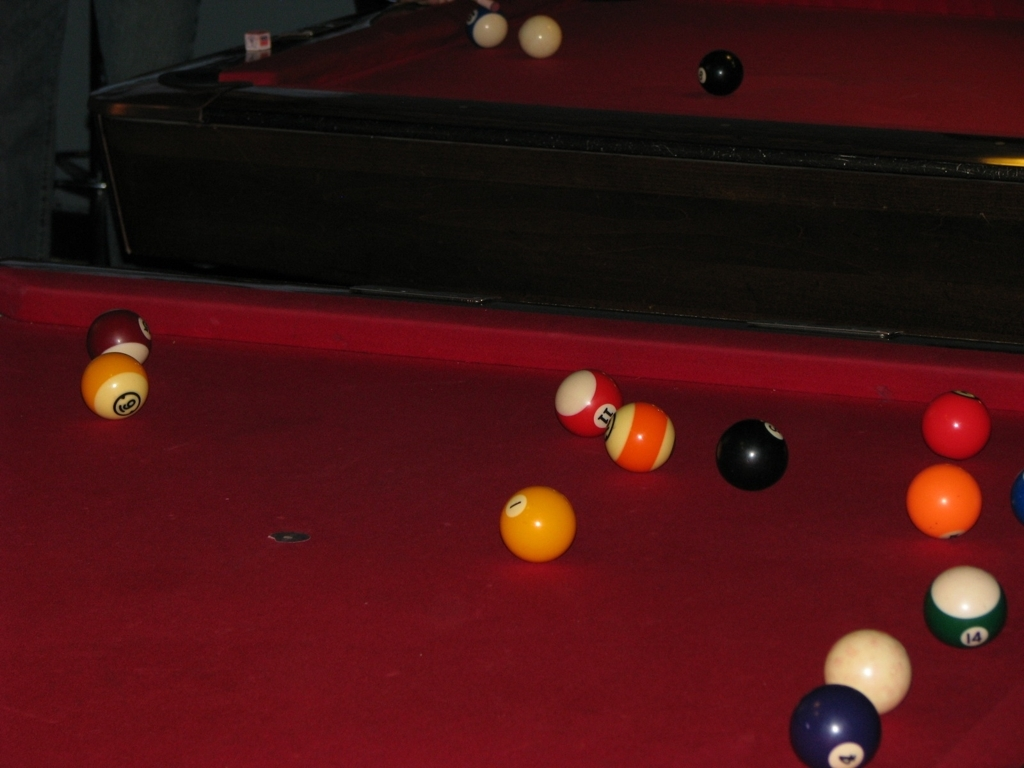How is the lighting in this image?
A. The lighting in this image is terrible, with dull colors.
B. The lighting in this image is acceptable, with vibrant colors.
C. The lighting in this image is outstanding, with neutral colors. The lighting in this image creates a warm atmosphere that highlights the rich colors of the pool balls, with a balance between light and shadow that adds depth to the scene. However, some areas appear slightly underexposed, indicating room for improvement in lighting consistency. 